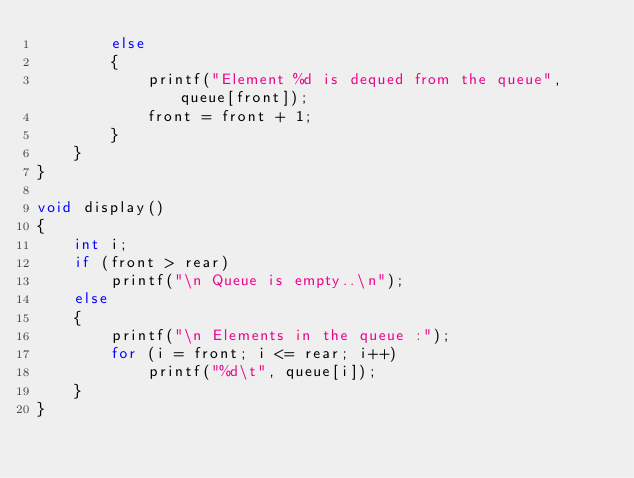<code> <loc_0><loc_0><loc_500><loc_500><_C_>        else
        {
            printf("Element %d is dequed from the queue", queue[front]);
            front = front + 1;
        }
    }
}

void display()
{
    int i;
    if (front > rear)
        printf("\n Queue is empty..\n");
    else
    {
        printf("\n Elements in the queue :");
        for (i = front; i <= rear; i++)
            printf("%d\t", queue[i]);
    }
}</code> 